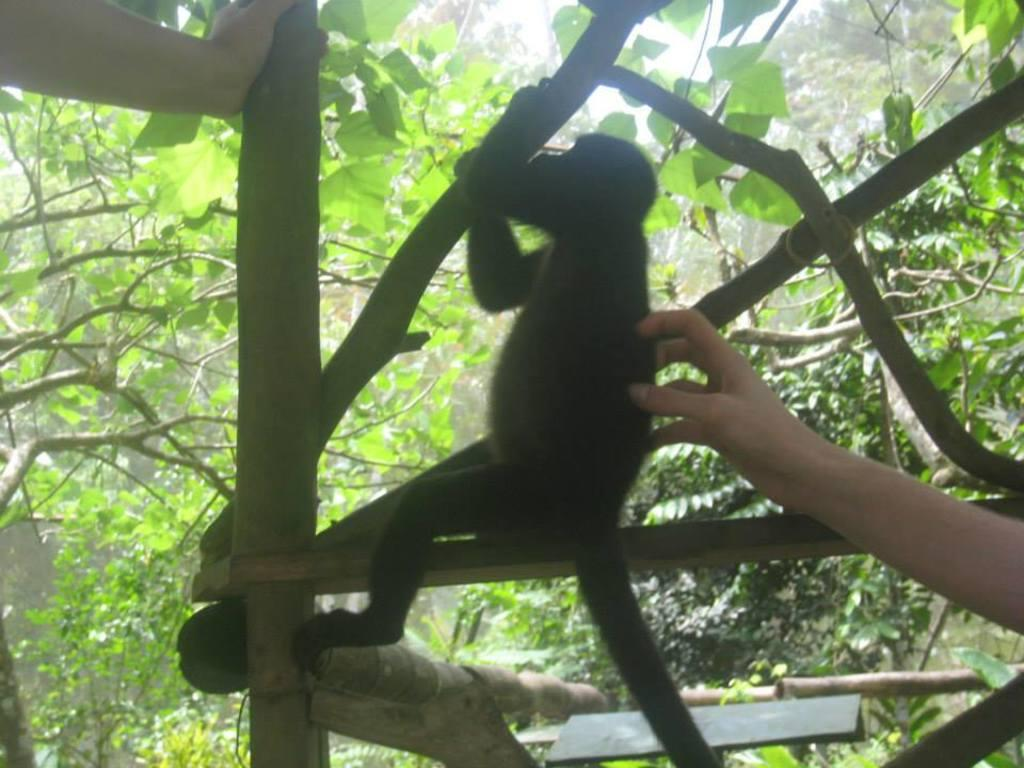What animal is present in the image? There is a monkey in the image. What is the monkey holding in the image? The monkey is holding a wooden log. What can be seen in the background of the image? There are trees in the background of the image. How many hands are visible in the image? There are two hands visible in the image. What type of question is being asked by the monkey in the image? There is no indication in the image that the monkey is asking a question. 